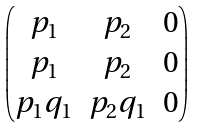Convert formula to latex. <formula><loc_0><loc_0><loc_500><loc_500>\begin{pmatrix} p _ { 1 } & p _ { 2 } & 0 \\ p _ { 1 } & p _ { 2 } & 0 \\ p _ { 1 } q _ { 1 } & p _ { 2 } q _ { 1 } & 0 \end{pmatrix}</formula> 